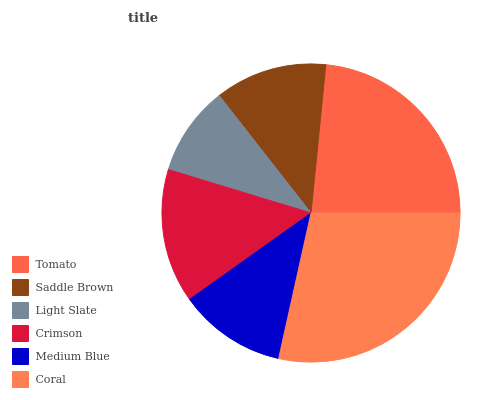Is Light Slate the minimum?
Answer yes or no. Yes. Is Coral the maximum?
Answer yes or no. Yes. Is Saddle Brown the minimum?
Answer yes or no. No. Is Saddle Brown the maximum?
Answer yes or no. No. Is Tomato greater than Saddle Brown?
Answer yes or no. Yes. Is Saddle Brown less than Tomato?
Answer yes or no. Yes. Is Saddle Brown greater than Tomato?
Answer yes or no. No. Is Tomato less than Saddle Brown?
Answer yes or no. No. Is Crimson the high median?
Answer yes or no. Yes. Is Saddle Brown the low median?
Answer yes or no. Yes. Is Medium Blue the high median?
Answer yes or no. No. Is Crimson the low median?
Answer yes or no. No. 